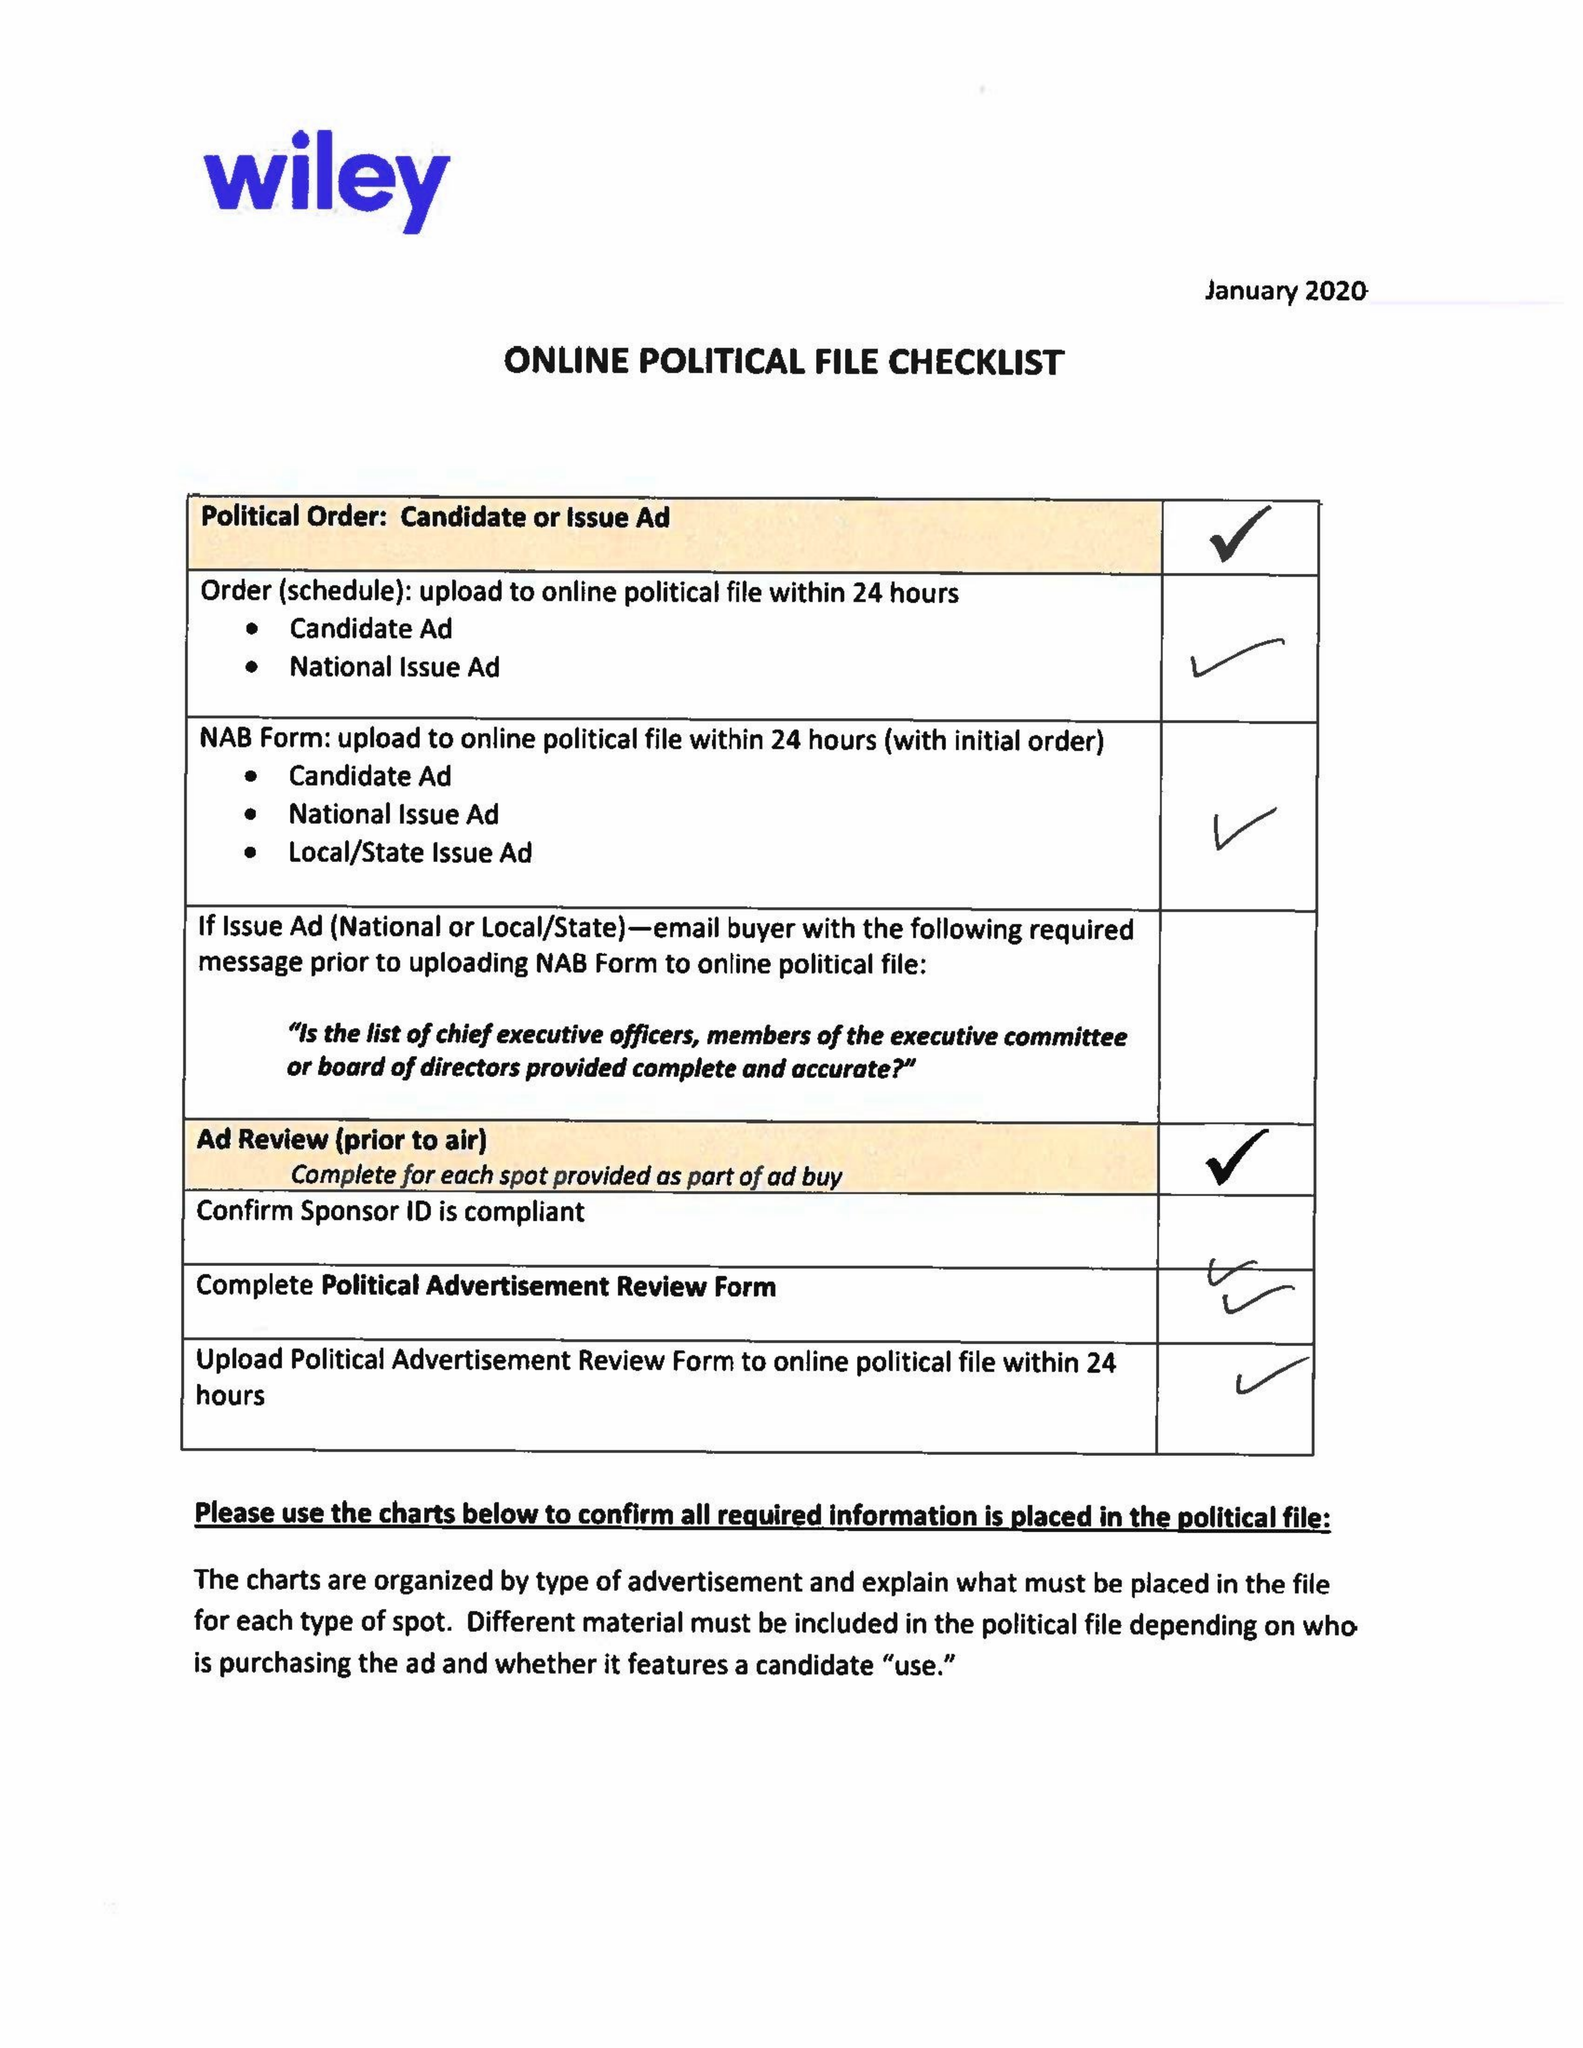What is the value for the flight_from?
Answer the question using a single word or phrase. 02/05/20 